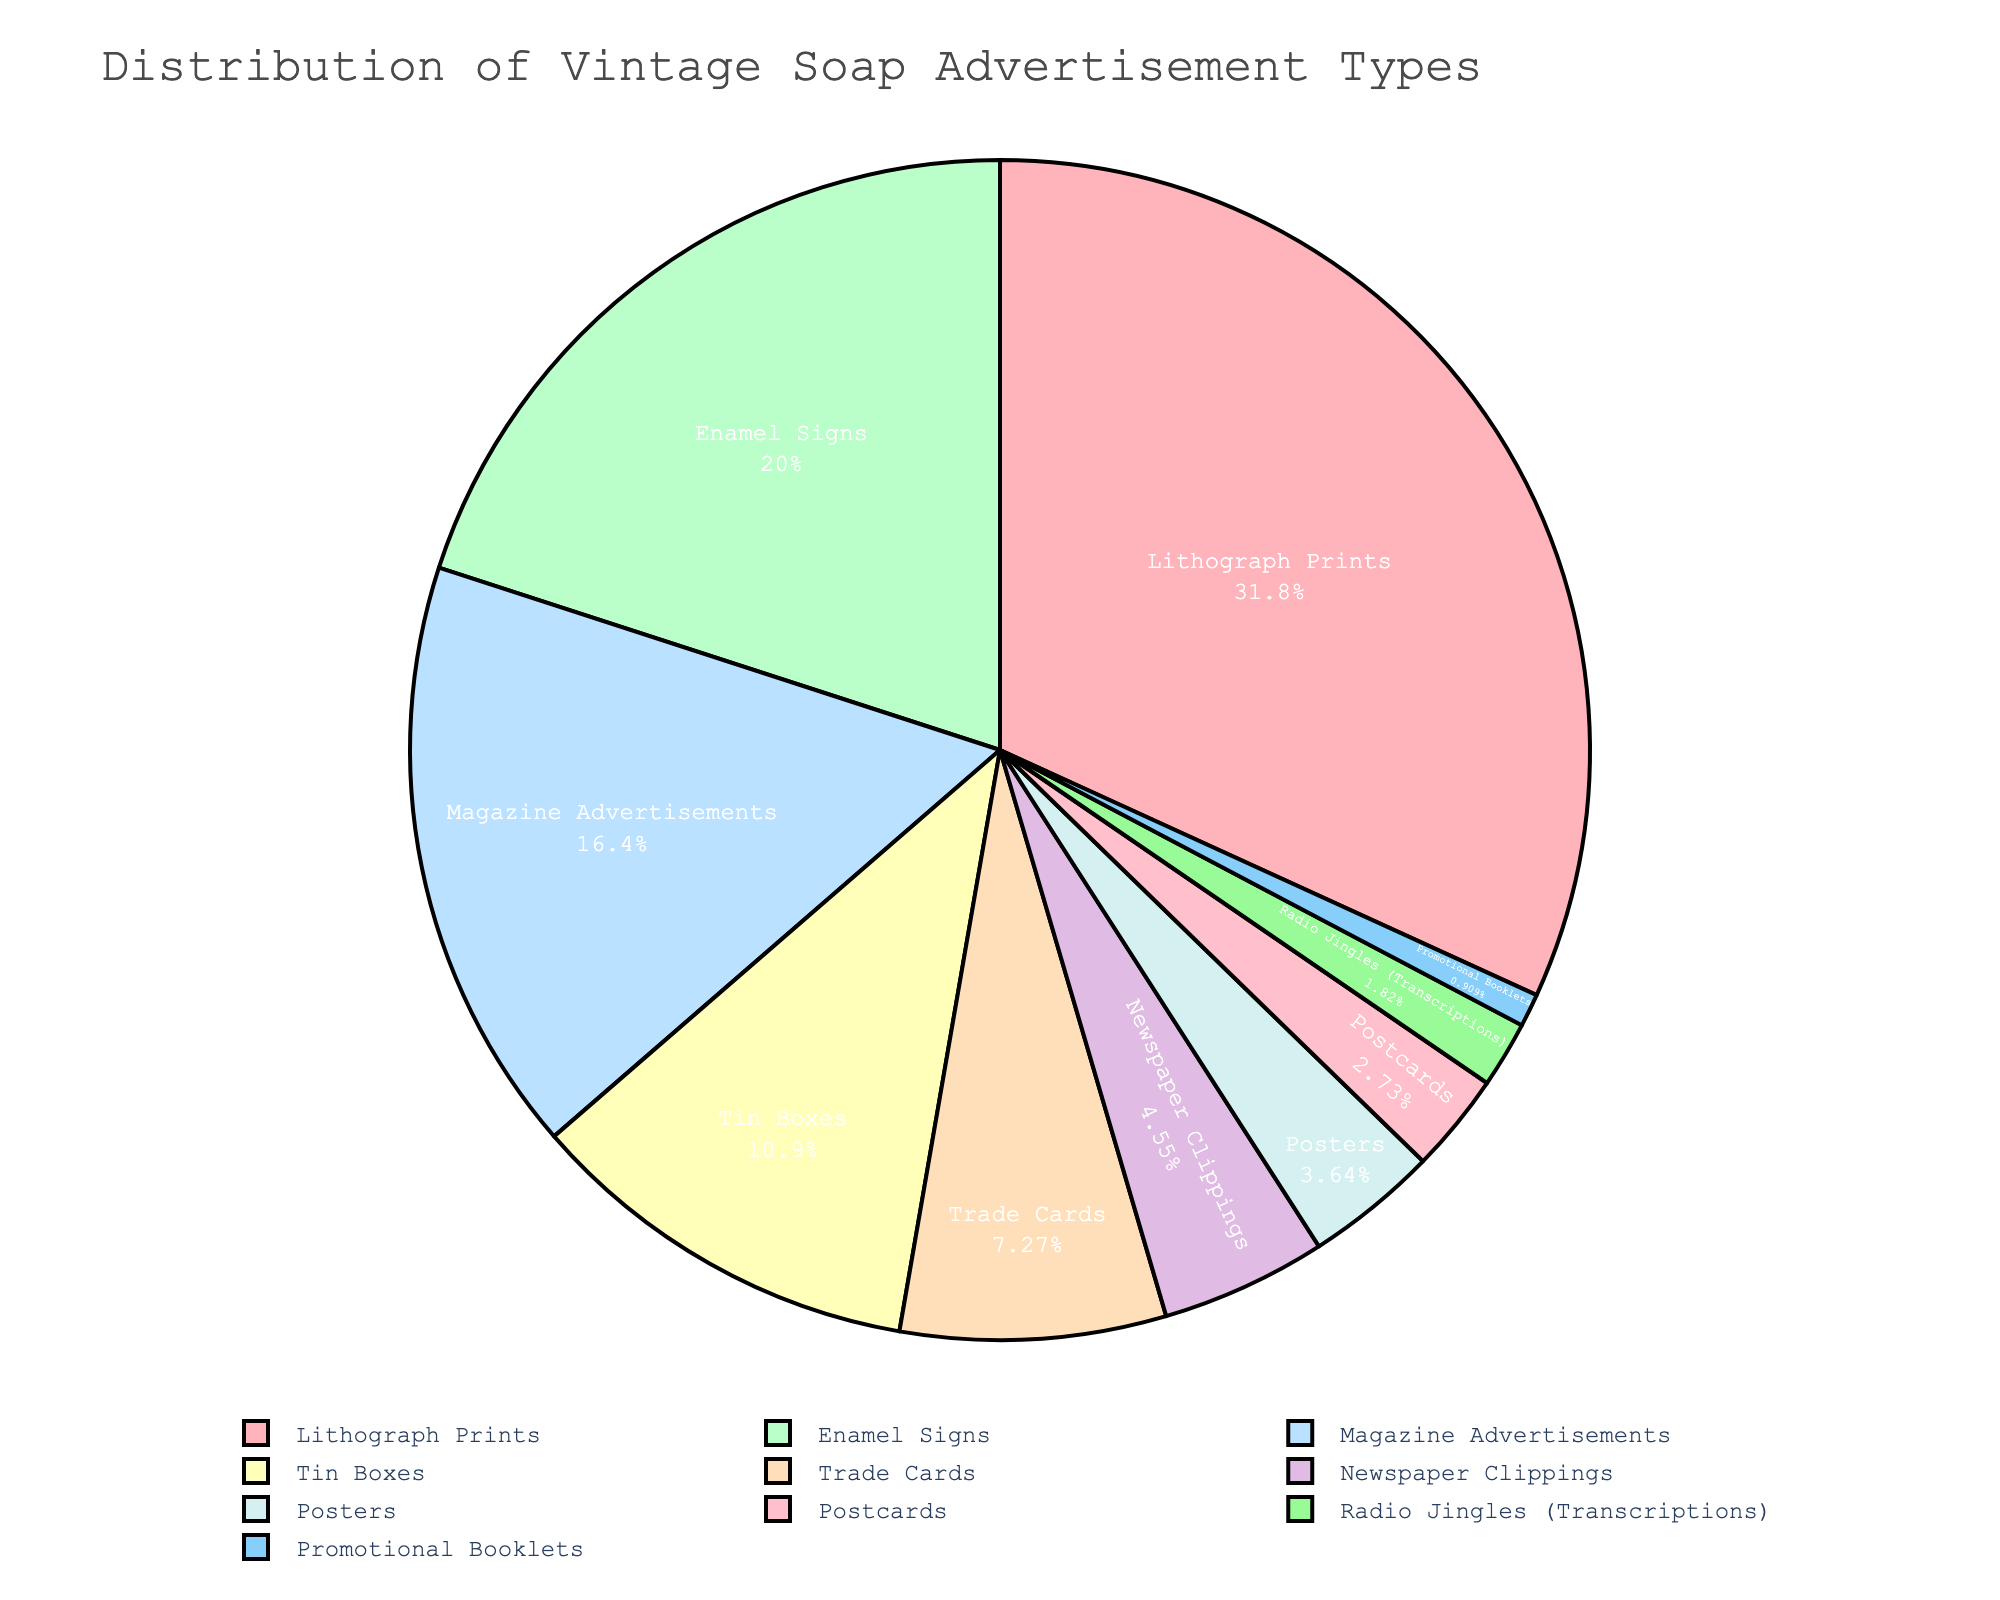What's the most common type of vintage soap advertisement in your collection? The pie chart shows that Lithograph Prints take up the largest section, with 35% of the collection.
Answer: Lithograph Prints How many advertisement types make up less than 10% of the collection? By looking at the pie chart, the advertisement types with less than 10% are Trade Cards, Newspaper Clippings, Posters, Postcards, Radio Jingles (Transcriptions), and Promotional Booklets. That's six types in total.
Answer: 6 What's the difference in percentage between Lithograph Prints and Magazine Advertisements? Lithograph Prints make up 35% of the collection, while Magazine Advertisements constitute 18%. The difference is 35 - 18 = 17%.
Answer: 17% Which advertisement type has an equal or smaller percentage compared to Trade Cards? Trade Cards have 8%. The types with equal or smaller percentages are Newspaper Clippings (5%), Posters (4%), Postcards (3%), Radio Jingles (2%), and Promotional Booklets (1%).
Answer: Newspaper Clippings, Posters, Postcards, Radio Jingles, Promotional Booklets What is the combined percentage of Tin Boxes and Enamel Signs advertisements? Tin Boxes make up 12% and Enamel Signs make up 22%. The combined percentage is 12 + 22 = 34%.
Answer: 34% Which advertisement types occupy the smallest sections of the pie chart based on their color? The smallest sections (tiny slices in pale colors) are Promotional Booklets (1%) and Radio Jingles (2%).
Answer: Promotional Booklets, Radio Jingles How much larger is the percentage of Lithograph Prints compared to Tin Boxes? Lithograph Prints constitute 35% and Tin Boxes are 12%. The difference in percentage is 35 - 12 = 23%.
Answer: 23% Arrange the advertisement types from largest to smallest percentage. Refer to the pie chart slices from largest to smallest: Lithograph Prints (35%), Enamel Signs (22%), Magazine Advertisements (18%), Tin Boxes (12%), Trade Cards (8%), Newspaper Clippings (5%), Posters (4%), Postcards (3%), Radio Jingles (2%), Promotional Booklets (1%).
Answer: Lithograph Prints, Enamel Signs, Magazine Advertisements, Tin Boxes, Trade Cards, Newspaper Clippings, Posters, Postcards, Radio Jingles, Promotional Booklets 